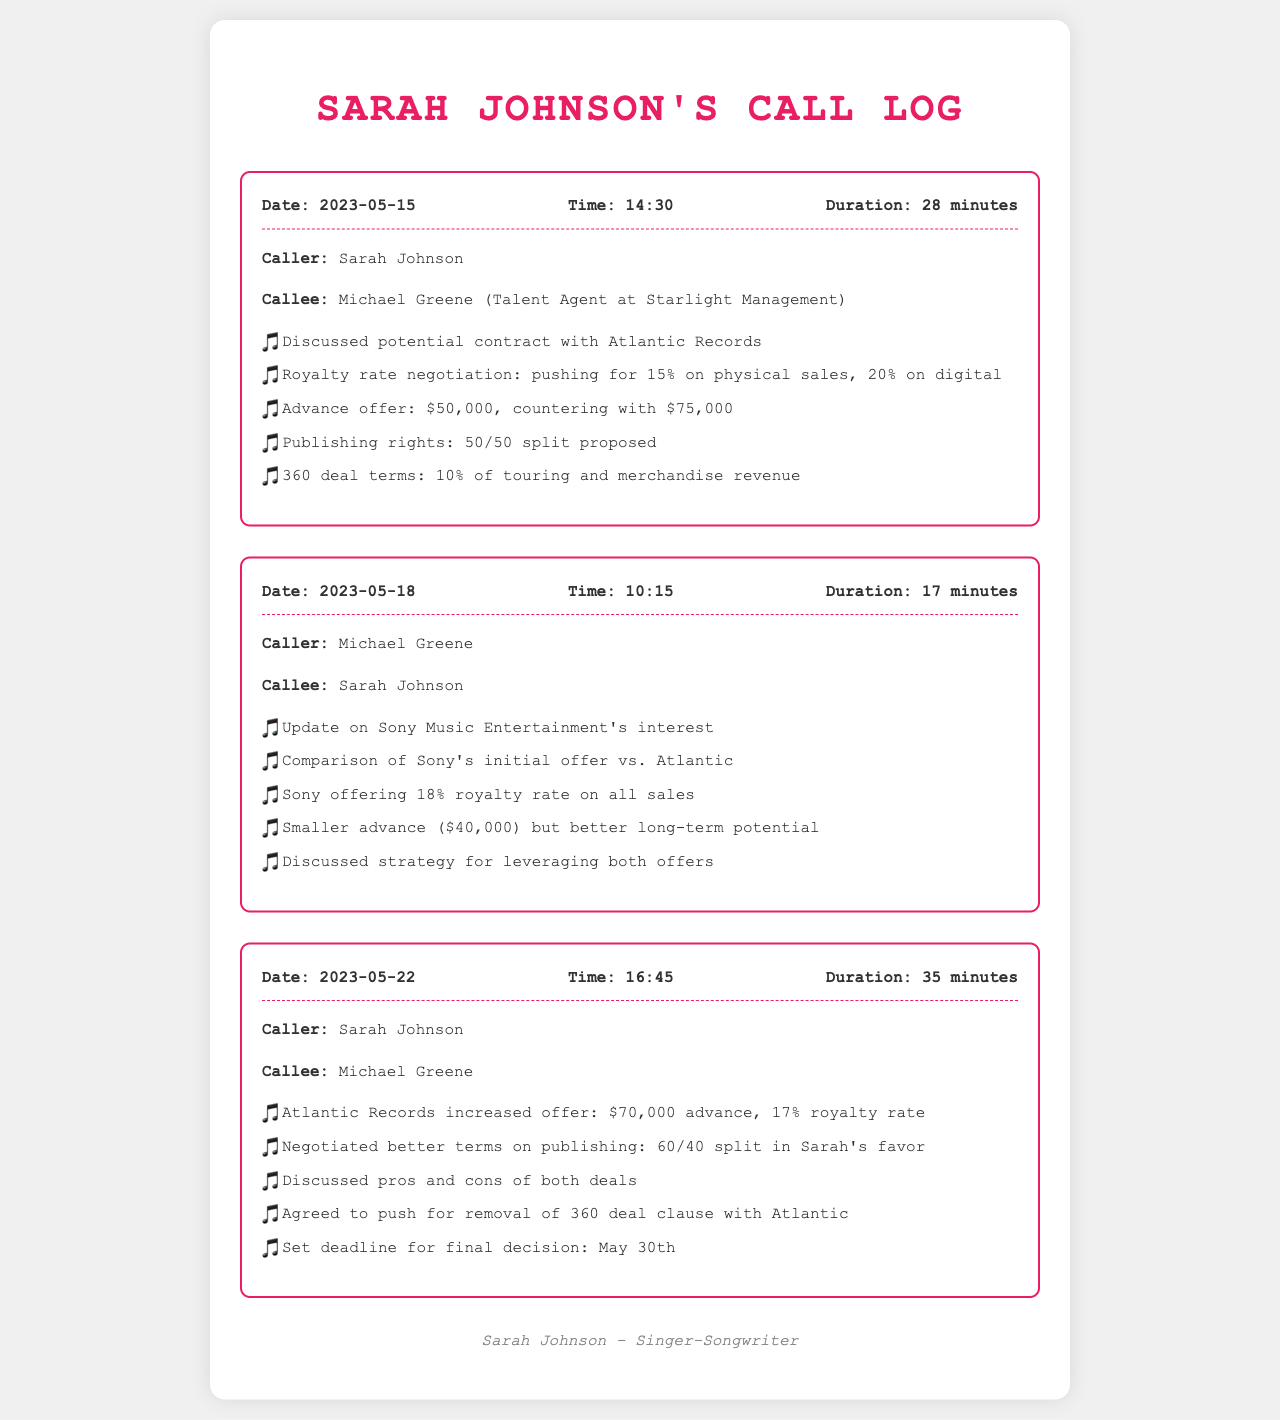What was the date of the first call? The date of the first call is listed in the document as May 15, 2023.
Answer: May 15, 2023 Who was the talent agent involved in the calls? The talent agent mentioned in the document is Michael Greene, who works at Starlight Management.
Answer: Michael Greene What was the initial advance offer from Atlantic Records? The document states that the initial advance offer from Atlantic Records was $50,000.
Answer: $50,000 What royalty rate did Sony Music offer? According to the call log, Sony offered an 18% royalty rate on all sales.
Answer: 18% What is the agreed deadline for the final decision on the contracts? The document specifies that the deadline for the final decision is May 30th.
Answer: May 30th What was the increased advance offer from Atlantic Records later in the discussions? The later increased offer from Atlantic Records mentioned in the calls was $70,000.
Answer: $70,000 What publishing rights split was proposed by Sarah during the negotiations? The proposed publishing rights split was a 60/40 split in Sarah's favor.
Answer: 60/40 split What was the duration of the call on May 22, 2023? The document states that the duration of the call on May 22, 2023, was 35 minutes.
Answer: 35 minutes What term did Sarah agree to push for removal during the negotiations? Sarah agreed to push for the removal of the 360 deal clause with Atlantic.
Answer: 360 deal clause 